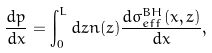<formula> <loc_0><loc_0><loc_500><loc_500>\frac { d p } { d x } = \int _ { 0 } ^ { L } d z n ( z ) \frac { d \sigma _ { e f f } ^ { B H } ( x , z ) } { d x } ,</formula> 